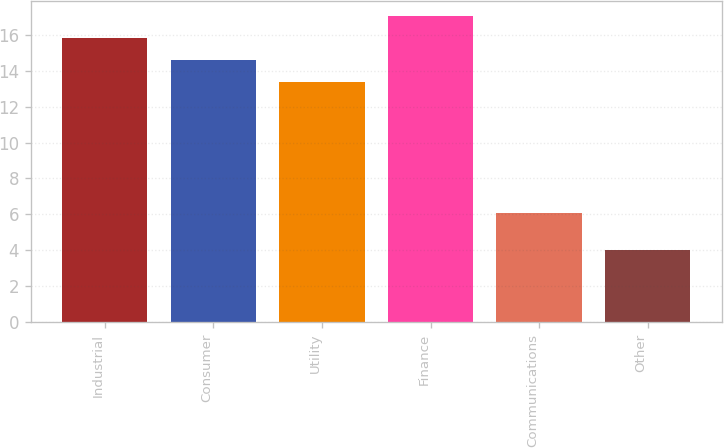<chart> <loc_0><loc_0><loc_500><loc_500><bar_chart><fcel>Industrial<fcel>Consumer<fcel>Utility<fcel>Finance<fcel>Communications<fcel>Other<nl><fcel>15.82<fcel>14.61<fcel>13.4<fcel>17.03<fcel>6.1<fcel>4<nl></chart> 